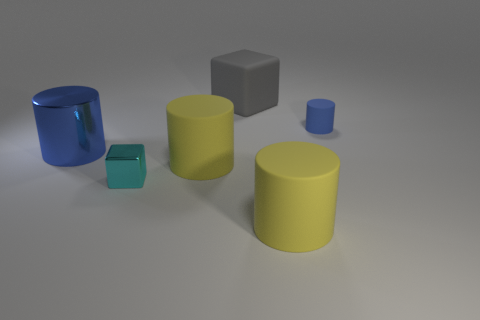Subtract all blue cylinders. How many were subtracted if there are1blue cylinders left? 1 Subtract all small cylinders. How many cylinders are left? 3 Add 3 yellow objects. How many objects exist? 9 Subtract all cyan cubes. How many cubes are left? 1 Subtract all cylinders. How many objects are left? 2 Subtract 2 blocks. How many blocks are left? 0 Subtract all brown spheres. How many yellow cylinders are left? 2 Add 3 gray things. How many gray things are left? 4 Add 2 gray cubes. How many gray cubes exist? 3 Subtract 1 yellow cylinders. How many objects are left? 5 